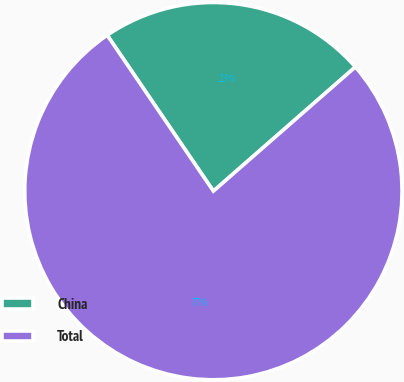Convert chart. <chart><loc_0><loc_0><loc_500><loc_500><pie_chart><fcel>China<fcel>Total<nl><fcel>23.08%<fcel>76.92%<nl></chart> 